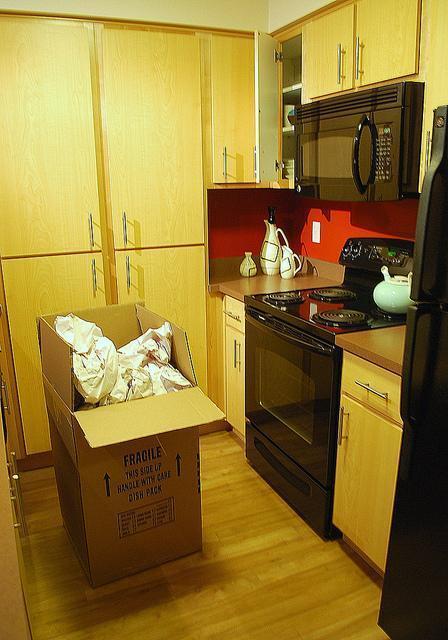How many white cars are on the road?
Give a very brief answer. 0. 